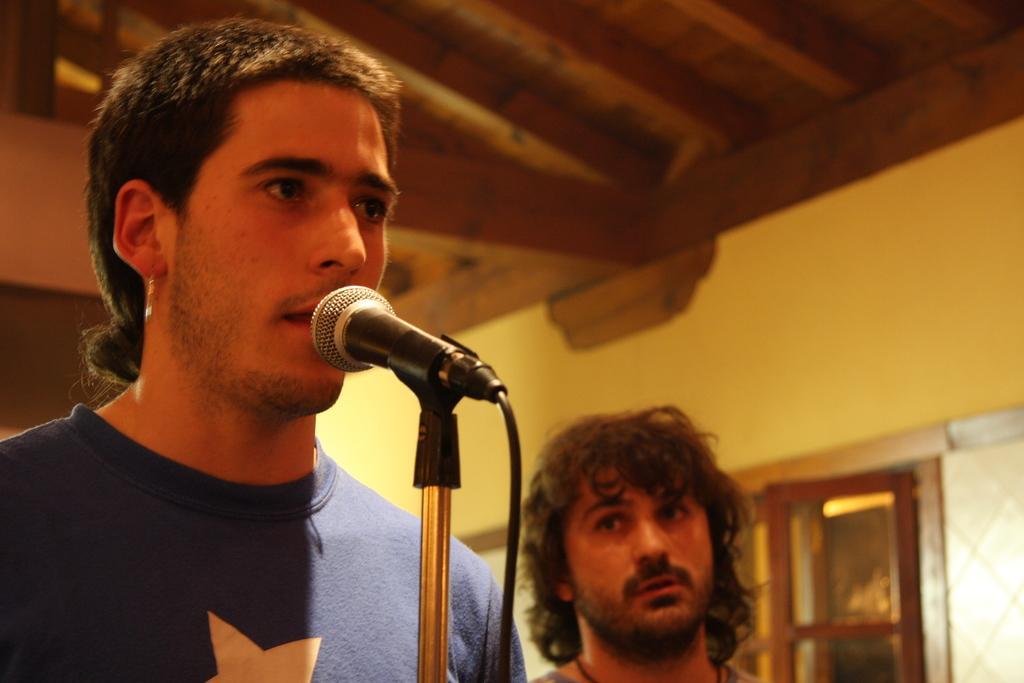Describe this image in one or two sentences. In this image I see 2 men and I see that this man is wearing a t-shirt and I see a tripod on which there is a mic and I see the black wire. In the background I see the wall. 